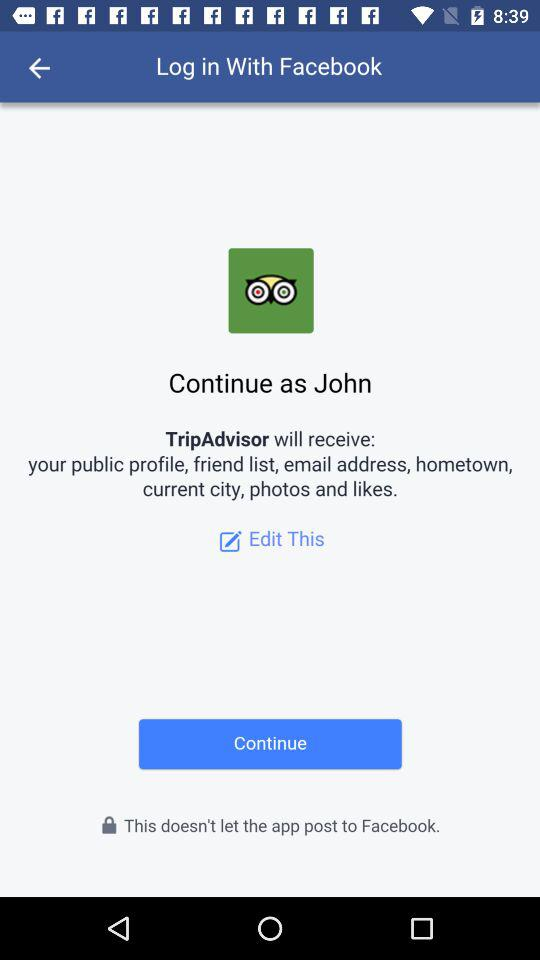What application will receive the public profile, friend list, email address, hometown, current city, photos and likes? The application "TripAdvisor" will receive the public profile, friend list, email address, hometown, current city, photos and likes. 